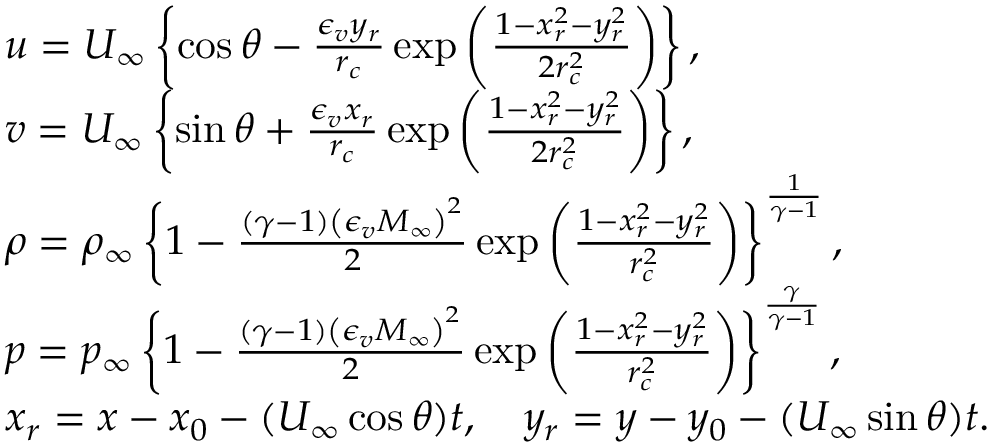Convert formula to latex. <formula><loc_0><loc_0><loc_500><loc_500>\begin{array} { r l } & { u = U _ { \infty } \left \{ \cos \theta - \frac { \epsilon _ { v } y _ { r } } { r _ { c } } \exp \left ( \frac { 1 - x _ { r } ^ { 2 } - y _ { r } ^ { 2 } } { 2 r _ { c } ^ { 2 } } \right ) \right \} , } \\ & { v = U _ { \infty } \left \{ \sin \theta + \frac { \epsilon _ { v } x _ { r } } { r _ { c } } \exp \left ( \frac { 1 - x _ { r } ^ { 2 } - y _ { r } ^ { 2 } } { 2 r _ { c } ^ { 2 } } \right ) \right \} , } \\ & { \rho = \rho _ { \infty } \left \{ 1 - \frac { ( \gamma - 1 ) \left ( \epsilon _ { v } M _ { \infty } \right ) ^ { 2 } } { 2 } \exp \left ( \frac { 1 - x _ { r } ^ { 2 } - y _ { r } ^ { 2 } } { r _ { c } ^ { 2 } } \right ) \right \} ^ { \frac { 1 } { \gamma - 1 } } , } \\ & { p = p _ { \infty } \left \{ 1 - \frac { ( \gamma - 1 ) \left ( \epsilon _ { v } M _ { \infty } \right ) ^ { 2 } } { 2 } \exp \left ( \frac { 1 - x _ { r } ^ { 2 } - y _ { r } ^ { 2 } } { r _ { c } ^ { 2 } } \right ) \right \} ^ { \frac { \gamma } { \gamma - 1 } } , } \\ & { x _ { r } = x - x _ { 0 } - ( U _ { \infty } \cos \theta ) t , \quad y _ { r } = y - y _ { 0 } - ( U _ { \infty } \sin \theta ) t . } \end{array}</formula> 